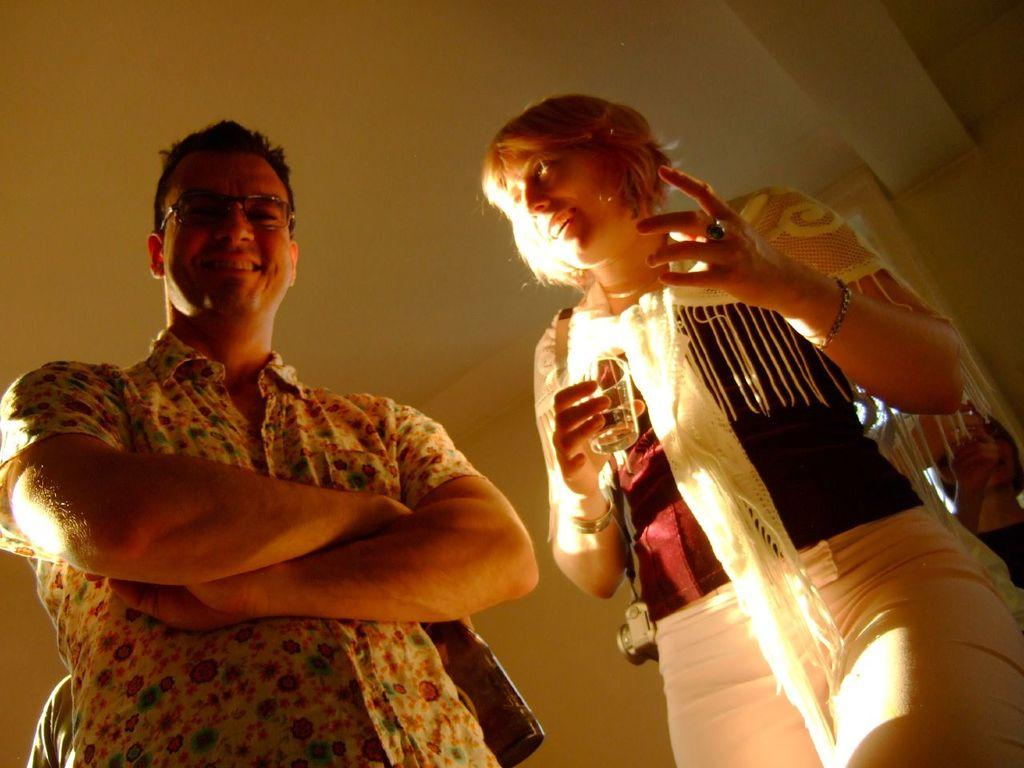How many people are in the image? There are two persons standing in the image. What is one of the persons holding? One of the persons is holding a glass in her hand. What can be seen in the background of the image? There is a wall in the background of the image. What is visible at the top of the image? There is a ceiling visible at the top of the image. What type of knife is the spy using to cut the doll in the image? There is no knife, spy, or doll present in the image. 